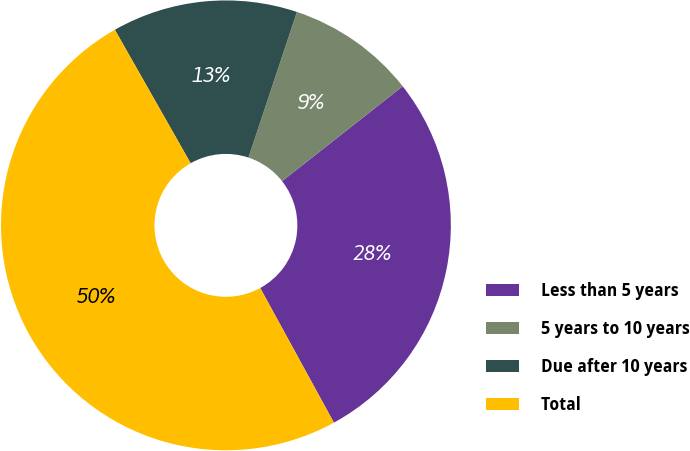Convert chart. <chart><loc_0><loc_0><loc_500><loc_500><pie_chart><fcel>Less than 5 years<fcel>5 years to 10 years<fcel>Due after 10 years<fcel>Total<nl><fcel>27.64%<fcel>9.28%<fcel>13.33%<fcel>49.75%<nl></chart> 